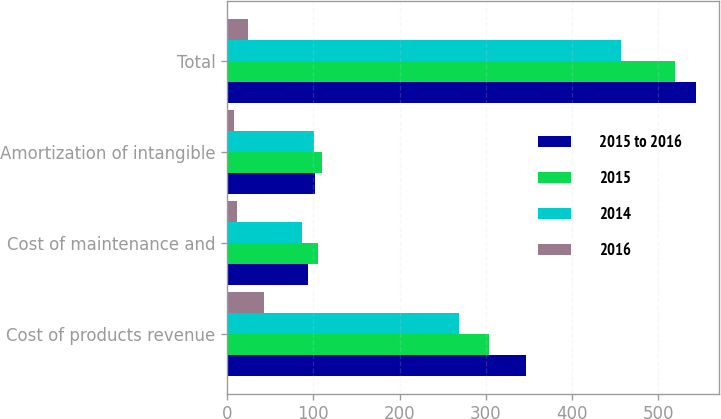Convert chart to OTSL. <chart><loc_0><loc_0><loc_500><loc_500><stacked_bar_chart><ecel><fcel>Cost of products revenue<fcel>Cost of maintenance and<fcel>Amortization of intangible<fcel>Total<nl><fcel>2015 to 2016<fcel>346.9<fcel>94<fcel>102.1<fcel>543<nl><fcel>2015<fcel>303.6<fcel>105.3<fcel>110<fcel>518.9<nl><fcel>2014<fcel>268.4<fcel>87.2<fcel>101.3<fcel>456.9<nl><fcel>2016<fcel>43.3<fcel>11.3<fcel>7.9<fcel>24.1<nl></chart> 